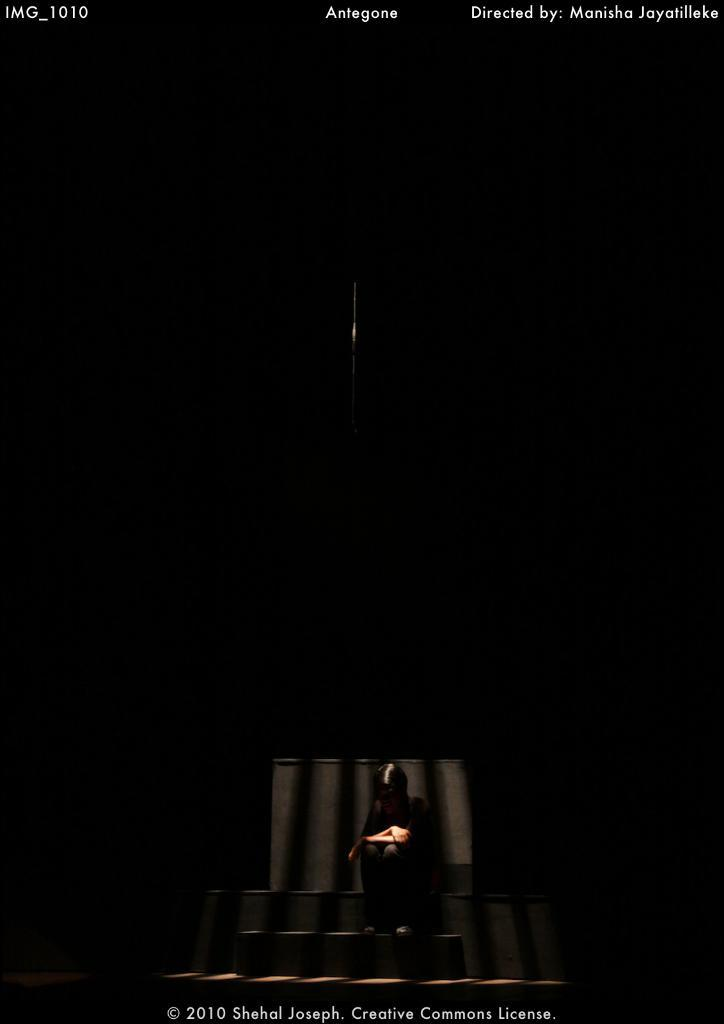Who is present in the image? There is a person in the image. What is the person wearing? The person is wearing a black dress. Where is the person sitting? The person is sitting on a bench or staircase. What is the color of the background in the image? The background of the image is black. What type of bell can be heard ringing in the image? There is no bell present in the image, and therefore no such sound can be heard. 